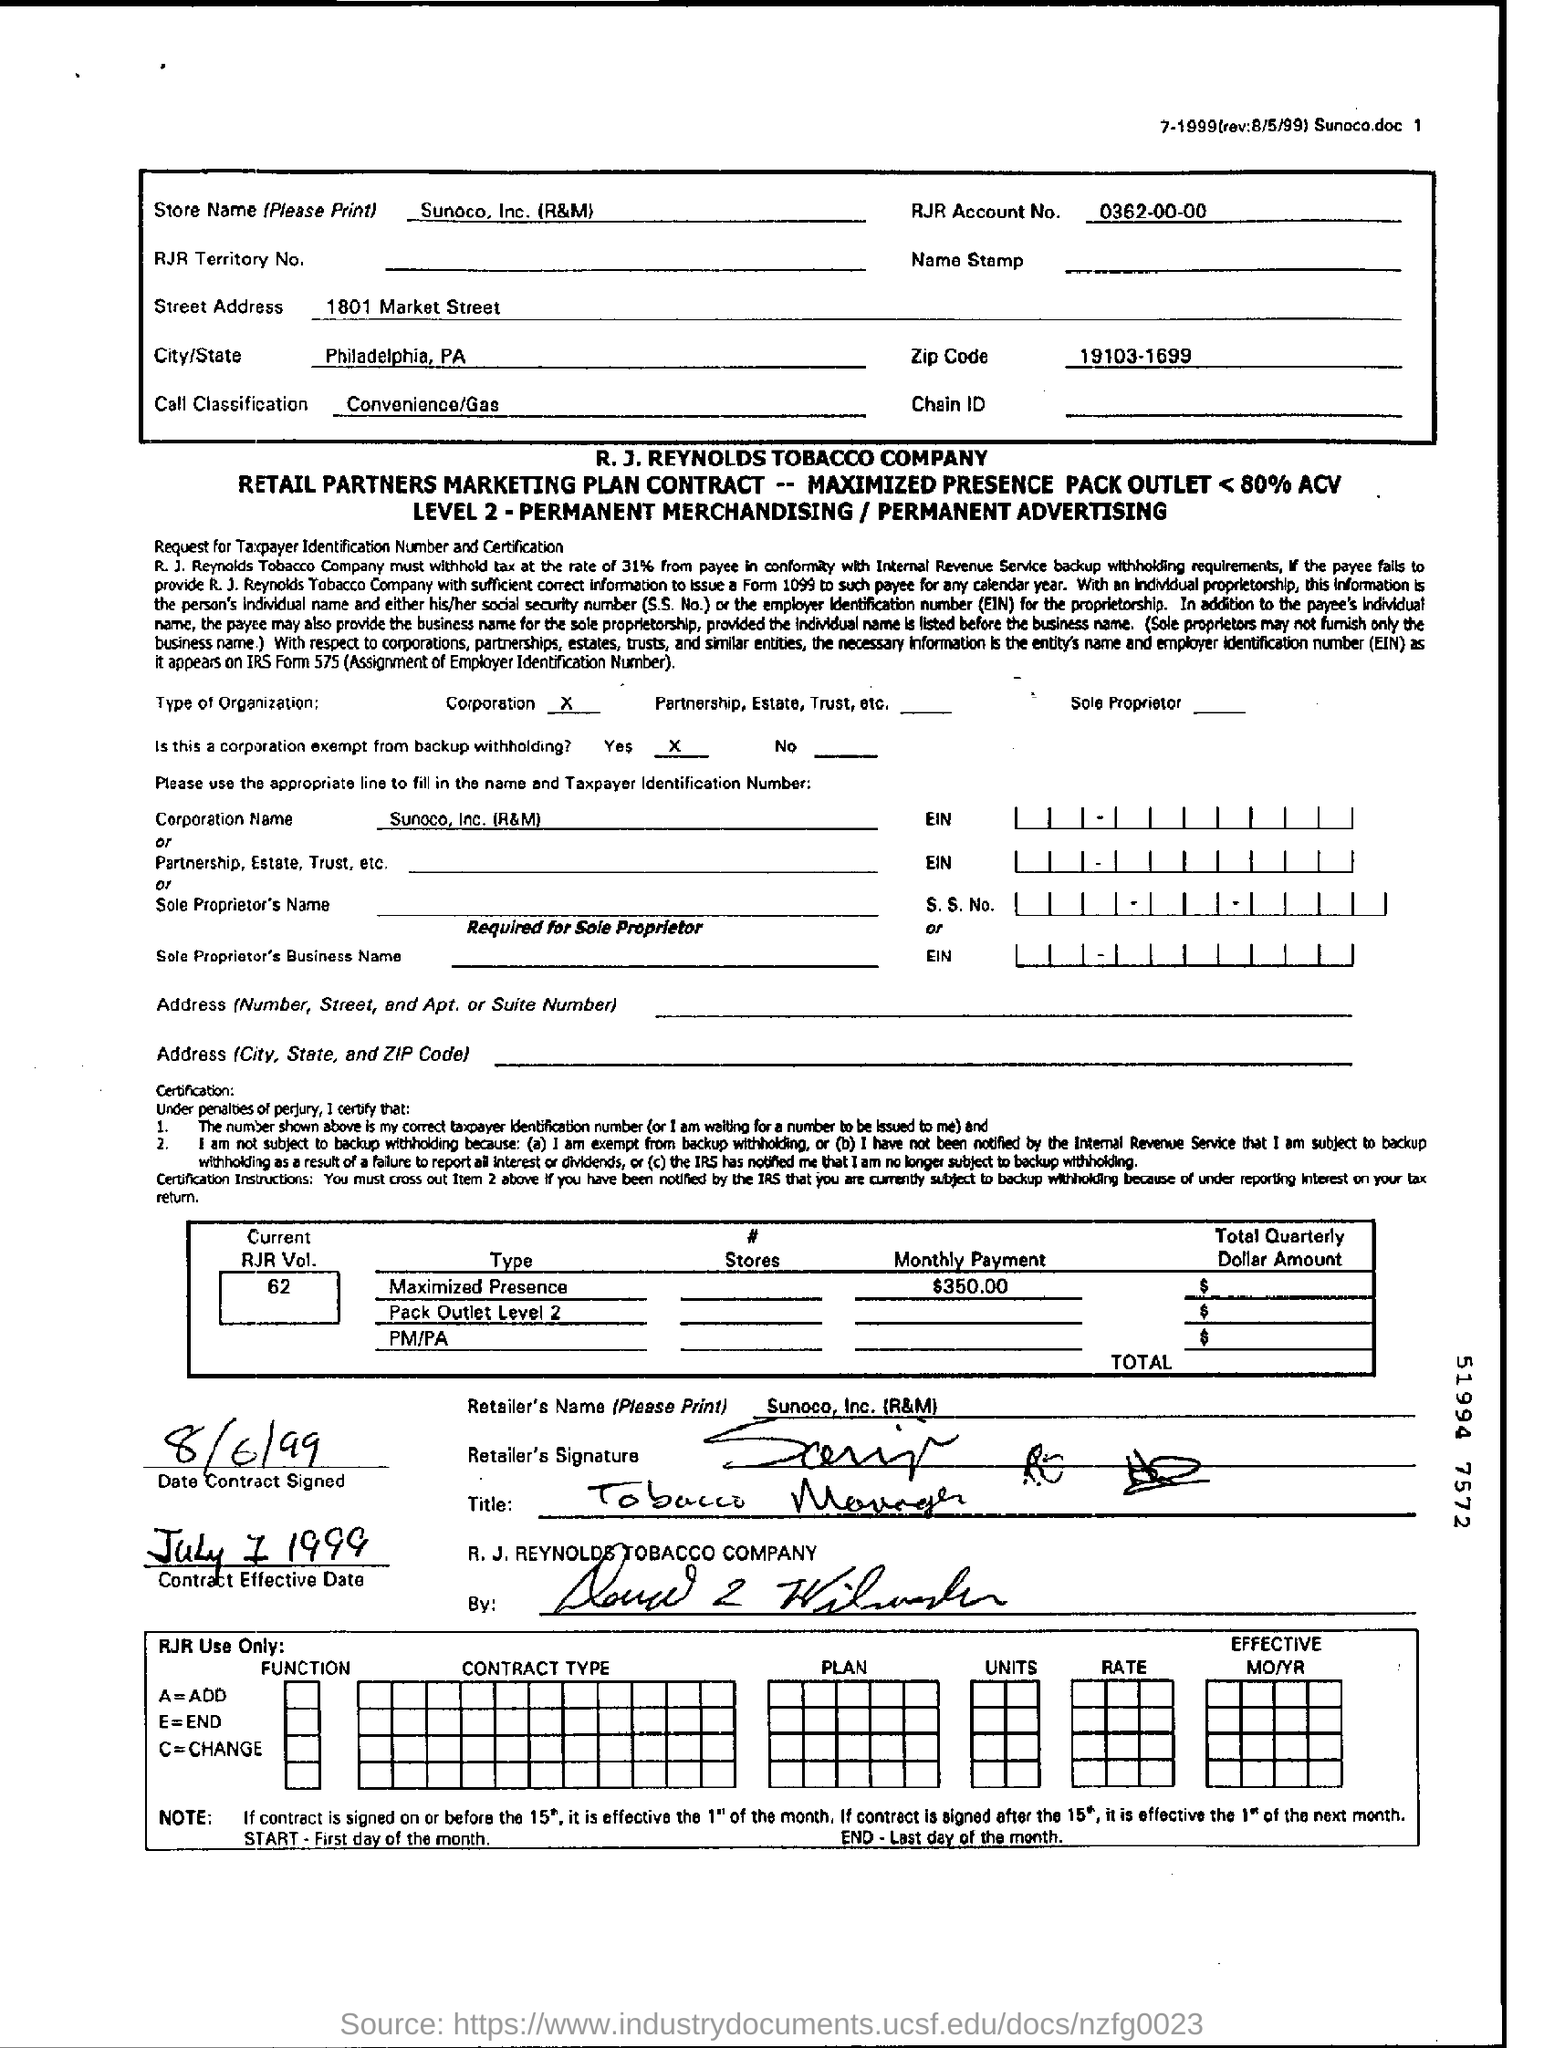When was this Contract signed?
Your answer should be compact. 8/6/99. What is the name of the City mentioned in the box?
Your response must be concise. Philadelphia. What is the zip code?
Give a very brief answer. 19103-1699. 